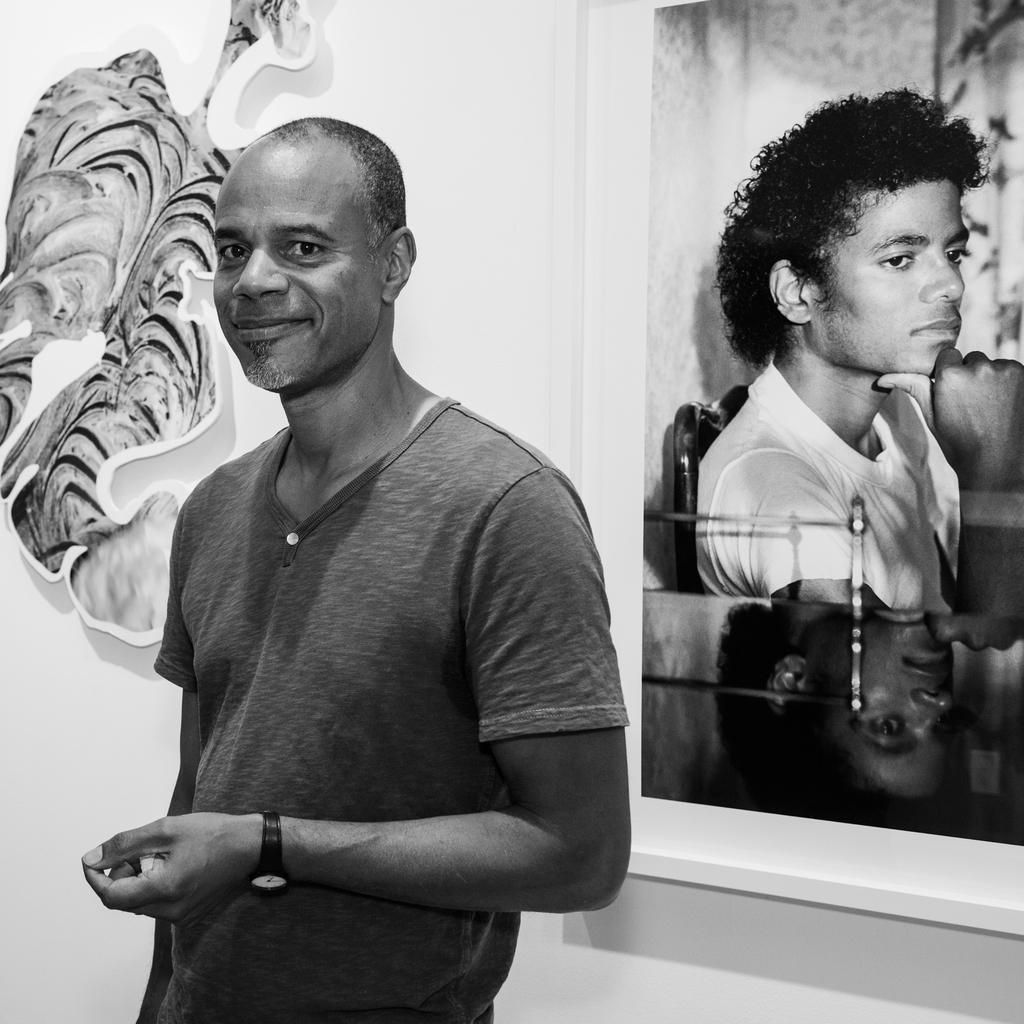Describe this image in one or two sentences. This is a black and white image. In this image we can see a person standing. On the backside we can see a sticker and a photo frame to a wall. 